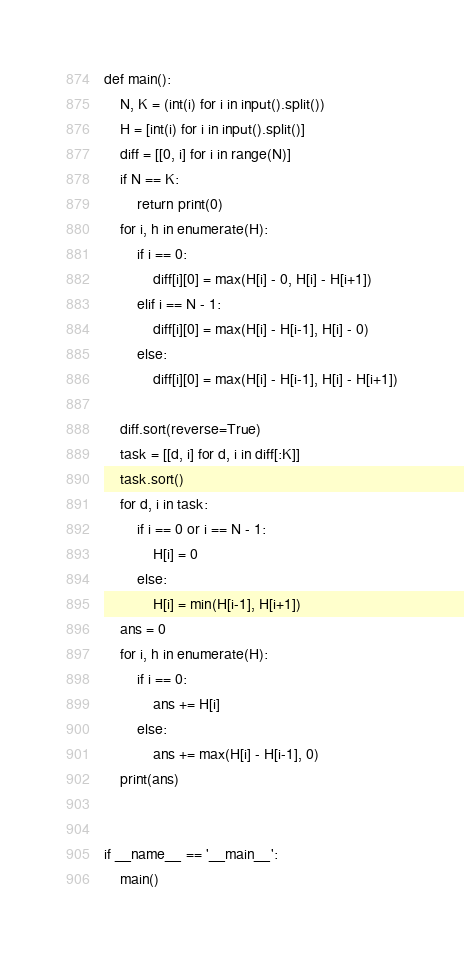Convert code to text. <code><loc_0><loc_0><loc_500><loc_500><_Python_>def main():
    N, K = (int(i) for i in input().split())
    H = [int(i) for i in input().split()]
    diff = [[0, i] for i in range(N)]
    if N == K:
        return print(0)
    for i, h in enumerate(H):
        if i == 0:
            diff[i][0] = max(H[i] - 0, H[i] - H[i+1])
        elif i == N - 1:
            diff[i][0] = max(H[i] - H[i-1], H[i] - 0)
        else:
            diff[i][0] = max(H[i] - H[i-1], H[i] - H[i+1])

    diff.sort(reverse=True)
    task = [[d, i] for d, i in diff[:K]]
    task.sort()
    for d, i in task:
        if i == 0 or i == N - 1:
            H[i] = 0
        else:
            H[i] = min(H[i-1], H[i+1])
    ans = 0
    for i, h in enumerate(H):
        if i == 0:
            ans += H[i]
        else:
            ans += max(H[i] - H[i-1], 0)
    print(ans)


if __name__ == '__main__':
    main()
</code> 